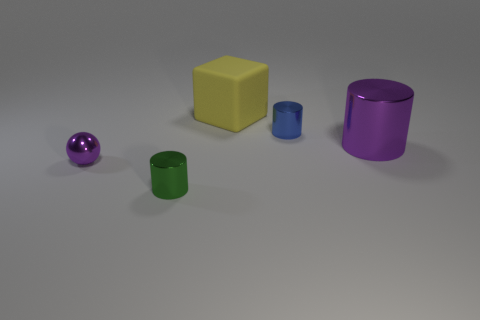How many things are either large purple things on the right side of the yellow thing or tiny things?
Your answer should be compact. 4. There is another tiny cylinder that is made of the same material as the green cylinder; what is its color?
Offer a terse response. Blue. Is there a green object of the same size as the blue shiny thing?
Offer a terse response. Yes. There is a tiny metallic thing behind the tiny metallic sphere; does it have the same color as the block?
Keep it short and to the point. No. There is a thing that is both in front of the big yellow matte thing and behind the large purple metallic object; what color is it?
Your response must be concise. Blue. There is a purple shiny object that is the same size as the green object; what is its shape?
Offer a terse response. Sphere. Is there a green shiny thing of the same shape as the small purple metal thing?
Your response must be concise. No. There is a green metal thing in front of the purple shiny cylinder; does it have the same size as the purple metal cylinder?
Your answer should be compact. No. There is a metallic thing that is in front of the tiny blue shiny thing and behind the tiny metallic ball; what size is it?
Your answer should be compact. Large. What number of other things are made of the same material as the yellow cube?
Keep it short and to the point. 0. 